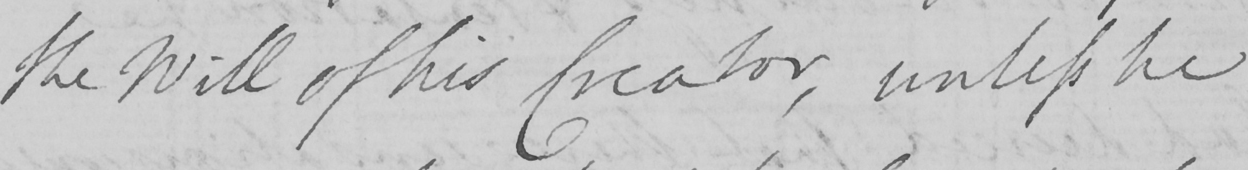Please provide the text content of this handwritten line. the Will of his Creator , unless he 